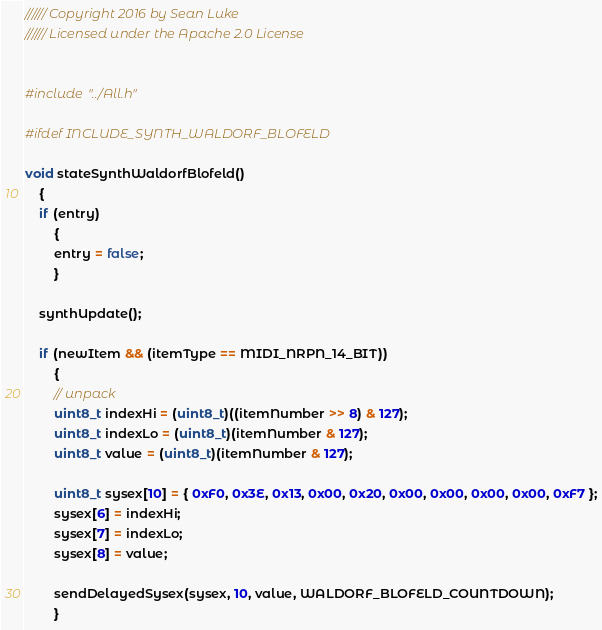Convert code to text. <code><loc_0><loc_0><loc_500><loc_500><_C++_>////// Copyright 2016 by Sean Luke
////// Licensed under the Apache 2.0 License


#include "../All.h"

#ifdef INCLUDE_SYNTH_WALDORF_BLOFELD

void stateSynthWaldorfBlofeld()
    {
    if (entry)
        {
        entry = false;
        }
    
    synthUpdate();
    
    if (newItem && (itemType == MIDI_NRPN_14_BIT))
        {
        // unpack
        uint8_t indexHi = (uint8_t)((itemNumber >> 8) & 127);
        uint8_t indexLo = (uint8_t)(itemNumber & 127);
        uint8_t value = (uint8_t)(itemNumber & 127);
        
        uint8_t sysex[10] = { 0xF0, 0x3E, 0x13, 0x00, 0x20, 0x00, 0x00, 0x00, 0x00, 0xF7 };
        sysex[6] = indexHi;
        sysex[7] = indexLo;
        sysex[8] = value;

        sendDelayedSysex(sysex, 10, value, WALDORF_BLOFELD_COUNTDOWN);
        }
</code> 